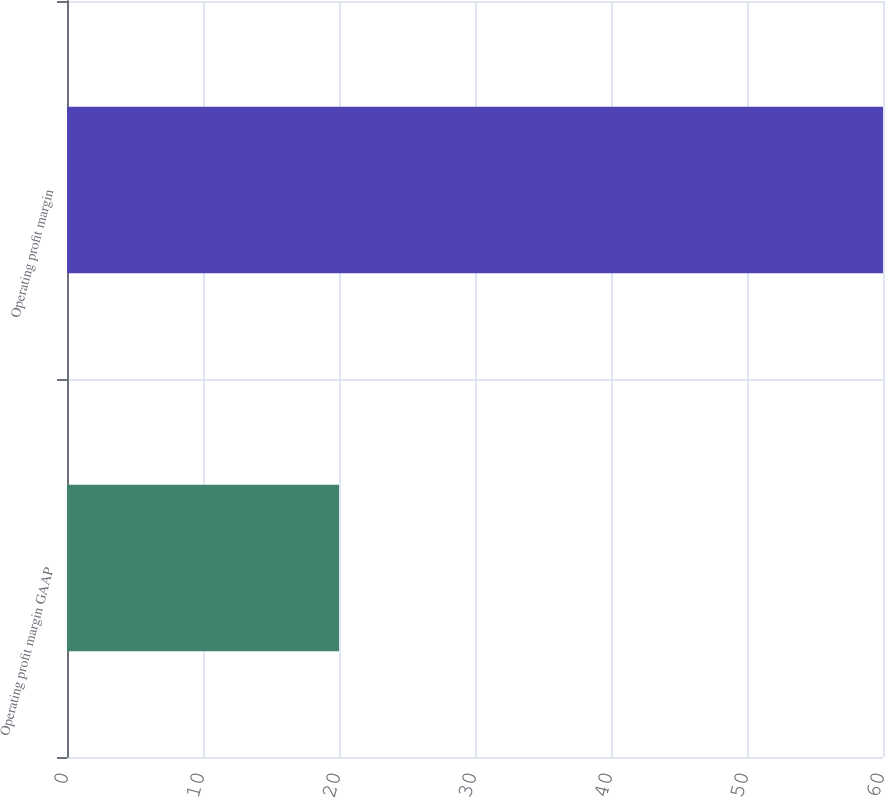Convert chart to OTSL. <chart><loc_0><loc_0><loc_500><loc_500><bar_chart><fcel>Operating profit margin GAAP<fcel>Operating profit margin<nl><fcel>20<fcel>60<nl></chart> 